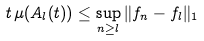Convert formula to latex. <formula><loc_0><loc_0><loc_500><loc_500>t \, \mu ( A _ { l } ( t ) ) \leq \sup _ { n \geq l } \| f _ { n } - f _ { l } \| _ { 1 }</formula> 